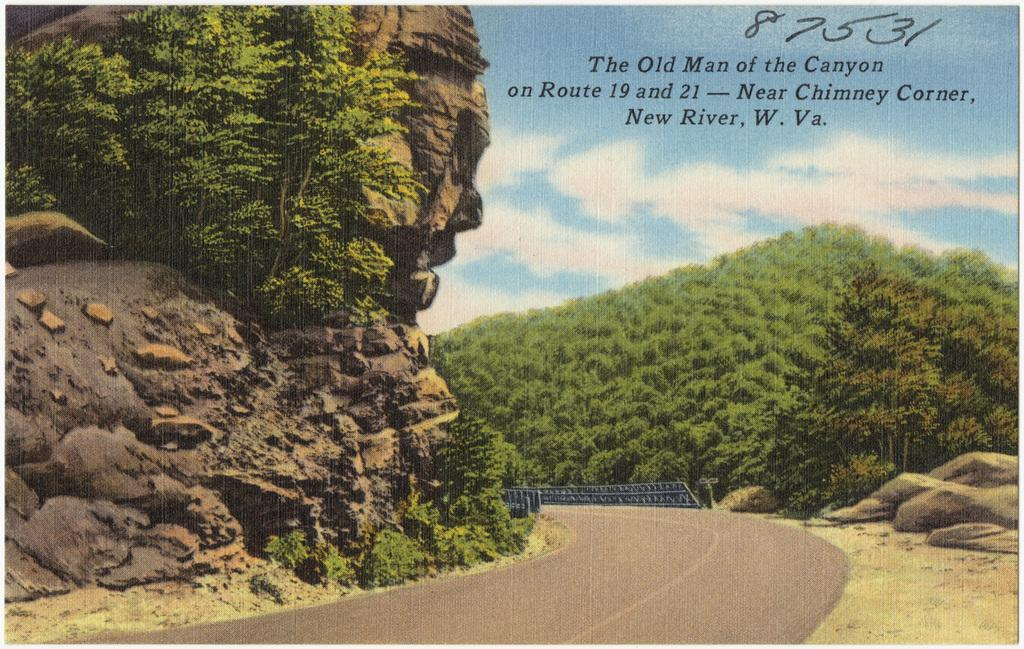What is featured on the poster in the image? The information about the poster's content is not provided in the facts. What type of natural elements can be seen in the image? There are trees, rocks, and stones in the image. What man-made structures are present in the image? There is a road and a railing in the image. What is visible at the top of the image? The sky is visible at the top of the image. What is the weather like in the image? The sky appears to be cloudy in the image. What type of silverware is being used in the bath in the image? There is no mention of silverware or a bath in the image. The image features a poster, trees, rocks, stones, a road, a railing, and a cloudy sky. 